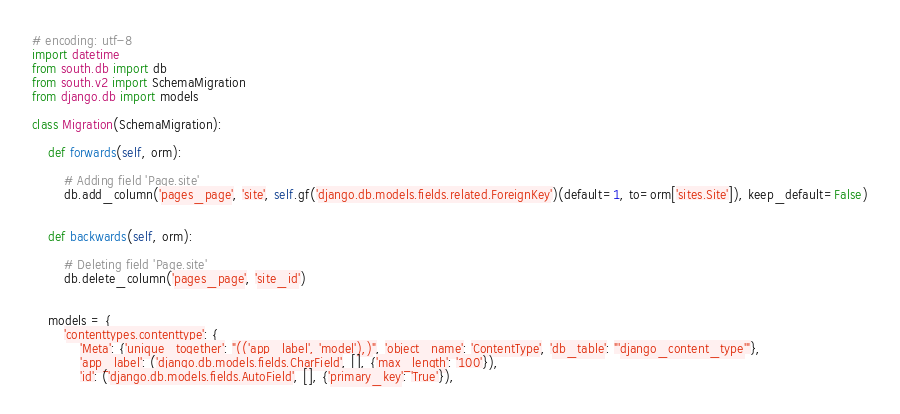Convert code to text. <code><loc_0><loc_0><loc_500><loc_500><_Python_># encoding: utf-8
import datetime
from south.db import db
from south.v2 import SchemaMigration
from django.db import models

class Migration(SchemaMigration):
    
    def forwards(self, orm):
        
        # Adding field 'Page.site'
        db.add_column('pages_page', 'site', self.gf('django.db.models.fields.related.ForeignKey')(default=1, to=orm['sites.Site']), keep_default=False)
    
    
    def backwards(self, orm):
        
        # Deleting field 'Page.site'
        db.delete_column('pages_page', 'site_id')
    
    
    models = {
        'contenttypes.contenttype': {
            'Meta': {'unique_together': "(('app_label', 'model'),)", 'object_name': 'ContentType', 'db_table': "'django_content_type'"},
            'app_label': ('django.db.models.fields.CharField', [], {'max_length': '100'}),
            'id': ('django.db.models.fields.AutoField', [], {'primary_key': 'True'}),</code> 